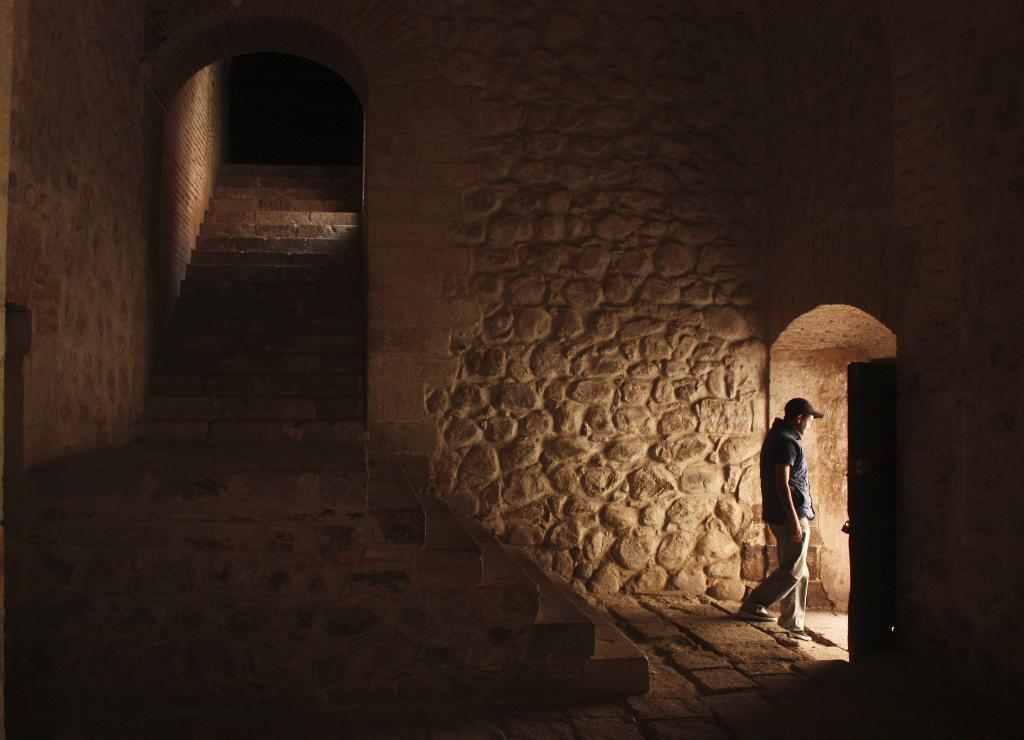What is the man in the image doing? The man is walking on the right side of the image. What can be seen in the center of the image? There are stairs in the center of the image. What type of path is visible in the image? There is a road in the image. What is located in the background of the image? There is a stone wall in the background of the image. What type of church can be seen in the image? There is no church present in the image. How many errors can be found in the image? There are no errors in the image, as it accurately depicts the man walking, stairs, road, and stone wall. 